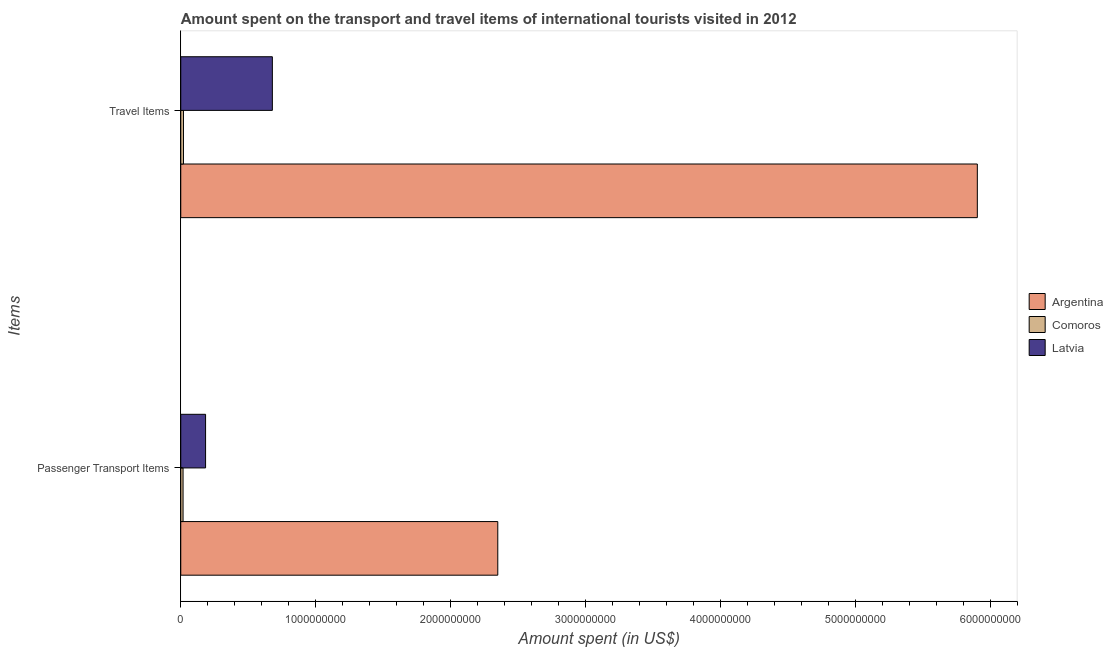How many groups of bars are there?
Your response must be concise. 2. Are the number of bars on each tick of the Y-axis equal?
Offer a very short reply. Yes. What is the label of the 2nd group of bars from the top?
Your answer should be compact. Passenger Transport Items. What is the amount spent in travel items in Comoros?
Offer a terse response. 2.00e+07. Across all countries, what is the maximum amount spent on passenger transport items?
Your response must be concise. 2.35e+09. Across all countries, what is the minimum amount spent in travel items?
Your response must be concise. 2.00e+07. In which country was the amount spent in travel items minimum?
Your response must be concise. Comoros. What is the total amount spent on passenger transport items in the graph?
Your answer should be compact. 2.55e+09. What is the difference between the amount spent on passenger transport items in Comoros and that in Latvia?
Your answer should be very brief. -1.67e+08. What is the difference between the amount spent in travel items in Comoros and the amount spent on passenger transport items in Argentina?
Your answer should be very brief. -2.33e+09. What is the average amount spent in travel items per country?
Keep it short and to the point. 2.20e+09. What is the difference between the amount spent on passenger transport items and amount spent in travel items in Comoros?
Provide a short and direct response. -3.00e+06. What is the ratio of the amount spent on passenger transport items in Comoros to that in Argentina?
Give a very brief answer. 0.01. In how many countries, is the amount spent on passenger transport items greater than the average amount spent on passenger transport items taken over all countries?
Your response must be concise. 1. What does the 2nd bar from the top in Passenger Transport Items represents?
Offer a very short reply. Comoros. What does the 2nd bar from the bottom in Passenger Transport Items represents?
Offer a very short reply. Comoros. How many bars are there?
Offer a terse response. 6. Are all the bars in the graph horizontal?
Provide a succinct answer. Yes. How many countries are there in the graph?
Give a very brief answer. 3. Where does the legend appear in the graph?
Offer a very short reply. Center right. How many legend labels are there?
Provide a succinct answer. 3. What is the title of the graph?
Your response must be concise. Amount spent on the transport and travel items of international tourists visited in 2012. What is the label or title of the X-axis?
Your answer should be very brief. Amount spent (in US$). What is the label or title of the Y-axis?
Provide a short and direct response. Items. What is the Amount spent (in US$) of Argentina in Passenger Transport Items?
Your answer should be compact. 2.35e+09. What is the Amount spent (in US$) of Comoros in Passenger Transport Items?
Make the answer very short. 1.70e+07. What is the Amount spent (in US$) of Latvia in Passenger Transport Items?
Offer a very short reply. 1.84e+08. What is the Amount spent (in US$) in Argentina in Travel Items?
Provide a short and direct response. 5.90e+09. What is the Amount spent (in US$) of Comoros in Travel Items?
Provide a succinct answer. 2.00e+07. What is the Amount spent (in US$) of Latvia in Travel Items?
Your answer should be very brief. 6.79e+08. Across all Items, what is the maximum Amount spent (in US$) in Argentina?
Your answer should be very brief. 5.90e+09. Across all Items, what is the maximum Amount spent (in US$) of Comoros?
Make the answer very short. 2.00e+07. Across all Items, what is the maximum Amount spent (in US$) in Latvia?
Offer a terse response. 6.79e+08. Across all Items, what is the minimum Amount spent (in US$) in Argentina?
Provide a short and direct response. 2.35e+09. Across all Items, what is the minimum Amount spent (in US$) of Comoros?
Make the answer very short. 1.70e+07. Across all Items, what is the minimum Amount spent (in US$) of Latvia?
Provide a short and direct response. 1.84e+08. What is the total Amount spent (in US$) in Argentina in the graph?
Offer a very short reply. 8.26e+09. What is the total Amount spent (in US$) in Comoros in the graph?
Your answer should be compact. 3.70e+07. What is the total Amount spent (in US$) of Latvia in the graph?
Give a very brief answer. 8.63e+08. What is the difference between the Amount spent (in US$) in Argentina in Passenger Transport Items and that in Travel Items?
Make the answer very short. -3.56e+09. What is the difference between the Amount spent (in US$) in Comoros in Passenger Transport Items and that in Travel Items?
Your answer should be very brief. -3.00e+06. What is the difference between the Amount spent (in US$) of Latvia in Passenger Transport Items and that in Travel Items?
Provide a succinct answer. -4.95e+08. What is the difference between the Amount spent (in US$) of Argentina in Passenger Transport Items and the Amount spent (in US$) of Comoros in Travel Items?
Make the answer very short. 2.33e+09. What is the difference between the Amount spent (in US$) in Argentina in Passenger Transport Items and the Amount spent (in US$) in Latvia in Travel Items?
Keep it short and to the point. 1.67e+09. What is the difference between the Amount spent (in US$) in Comoros in Passenger Transport Items and the Amount spent (in US$) in Latvia in Travel Items?
Give a very brief answer. -6.62e+08. What is the average Amount spent (in US$) in Argentina per Items?
Keep it short and to the point. 4.13e+09. What is the average Amount spent (in US$) of Comoros per Items?
Offer a very short reply. 1.85e+07. What is the average Amount spent (in US$) of Latvia per Items?
Provide a succinct answer. 4.32e+08. What is the difference between the Amount spent (in US$) in Argentina and Amount spent (in US$) in Comoros in Passenger Transport Items?
Offer a very short reply. 2.33e+09. What is the difference between the Amount spent (in US$) of Argentina and Amount spent (in US$) of Latvia in Passenger Transport Items?
Give a very brief answer. 2.17e+09. What is the difference between the Amount spent (in US$) of Comoros and Amount spent (in US$) of Latvia in Passenger Transport Items?
Provide a succinct answer. -1.67e+08. What is the difference between the Amount spent (in US$) in Argentina and Amount spent (in US$) in Comoros in Travel Items?
Offer a very short reply. 5.88e+09. What is the difference between the Amount spent (in US$) in Argentina and Amount spent (in US$) in Latvia in Travel Items?
Make the answer very short. 5.23e+09. What is the difference between the Amount spent (in US$) in Comoros and Amount spent (in US$) in Latvia in Travel Items?
Your answer should be very brief. -6.59e+08. What is the ratio of the Amount spent (in US$) in Argentina in Passenger Transport Items to that in Travel Items?
Make the answer very short. 0.4. What is the ratio of the Amount spent (in US$) in Comoros in Passenger Transport Items to that in Travel Items?
Make the answer very short. 0.85. What is the ratio of the Amount spent (in US$) in Latvia in Passenger Transport Items to that in Travel Items?
Offer a very short reply. 0.27. What is the difference between the highest and the second highest Amount spent (in US$) in Argentina?
Provide a short and direct response. 3.56e+09. What is the difference between the highest and the second highest Amount spent (in US$) of Comoros?
Ensure brevity in your answer.  3.00e+06. What is the difference between the highest and the second highest Amount spent (in US$) in Latvia?
Provide a short and direct response. 4.95e+08. What is the difference between the highest and the lowest Amount spent (in US$) in Argentina?
Ensure brevity in your answer.  3.56e+09. What is the difference between the highest and the lowest Amount spent (in US$) in Comoros?
Your answer should be compact. 3.00e+06. What is the difference between the highest and the lowest Amount spent (in US$) in Latvia?
Provide a succinct answer. 4.95e+08. 